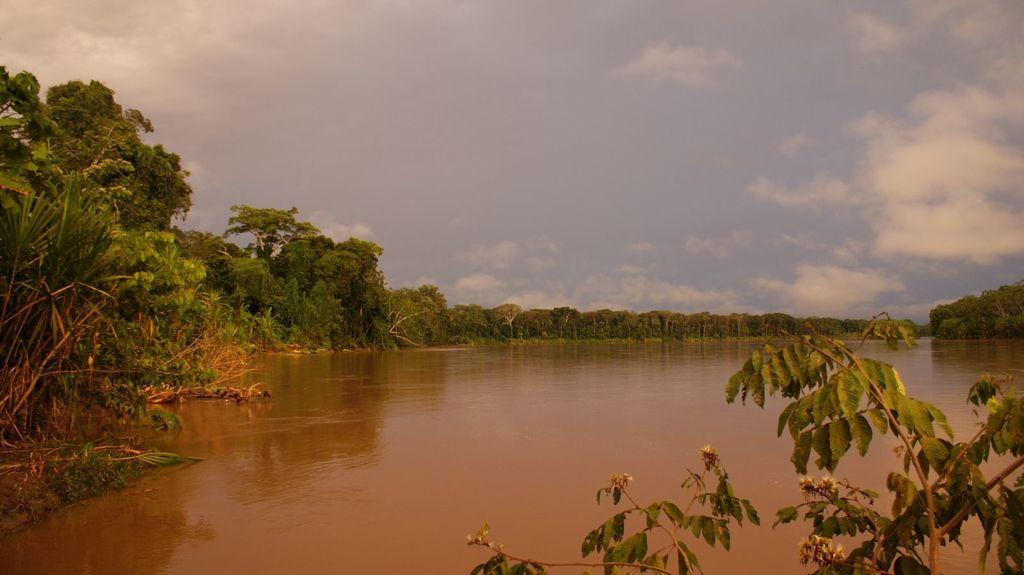What is the primary element visible in the image? There is water in the image. What type of vegetation is present around the water? There are trees around the water. How would you describe the sky in the image? The sky is blue and cloudy in the image. What type of hope can be seen growing near the water in the image? There is no hope visible in the image; it is a natural scene featuring water, trees, and a blue, cloudy sky. 